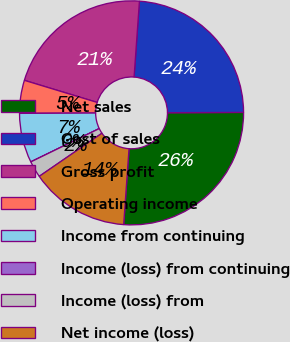Convert chart. <chart><loc_0><loc_0><loc_500><loc_500><pie_chart><fcel>Net sales<fcel>Cost of sales<fcel>Gross profit<fcel>Operating income<fcel>Income from continuing<fcel>Income (loss) from continuing<fcel>Income (loss) from<fcel>Net income (loss)<nl><fcel>26.19%<fcel>23.81%<fcel>21.43%<fcel>4.76%<fcel>7.14%<fcel>0.0%<fcel>2.38%<fcel>14.29%<nl></chart> 